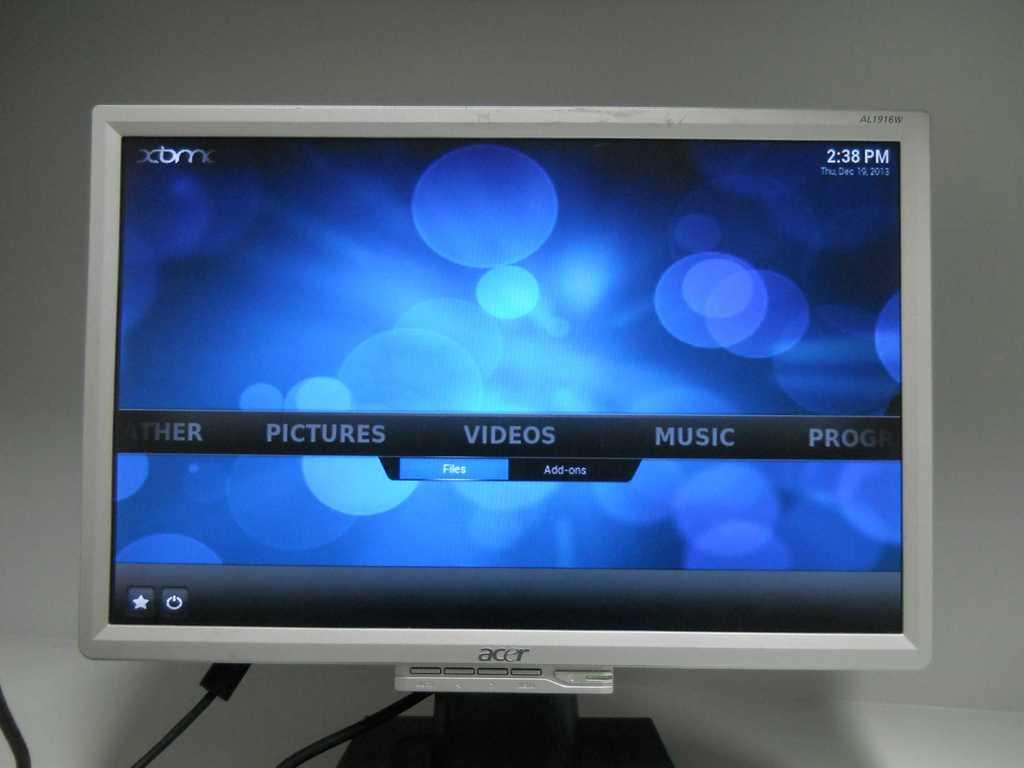What time is shown on the computer monitor?
Your response must be concise. 2:38pm. What is the time shown on the screen?
Provide a succinct answer. 2:38 pm. 